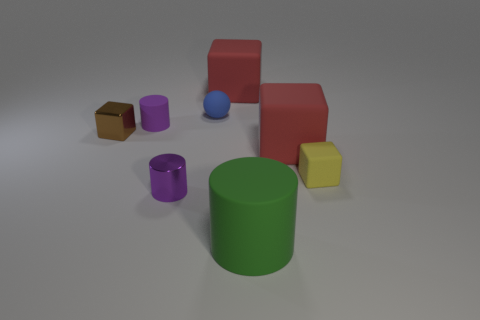Subtract all green cylinders. How many cylinders are left? 2 Subtract all purple cylinders. How many red cubes are left? 2 Subtract 1 cylinders. How many cylinders are left? 2 Subtract all yellow cubes. How many cubes are left? 3 Add 1 purple shiny cylinders. How many objects exist? 9 Subtract all cyan cylinders. Subtract all blue cubes. How many cylinders are left? 3 Subtract all spheres. How many objects are left? 7 Subtract all tiny blue cylinders. Subtract all large green cylinders. How many objects are left? 7 Add 8 metallic cubes. How many metallic cubes are left? 9 Add 3 green matte things. How many green matte things exist? 4 